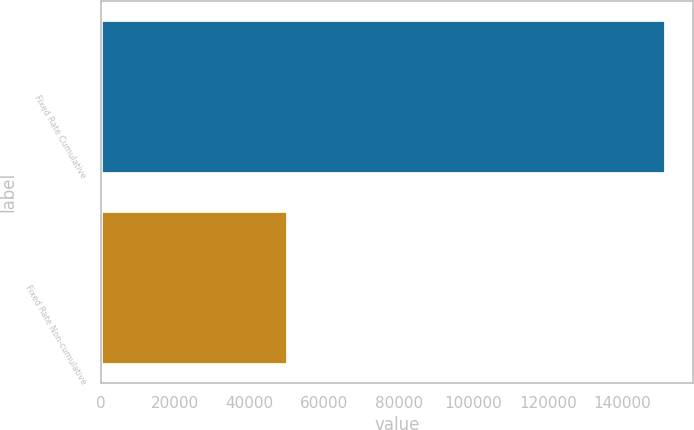Convert chart to OTSL. <chart><loc_0><loc_0><loc_500><loc_500><bar_chart><fcel>Fixed Rate Cumulative<fcel>Fixed Rate Non-cumulative<nl><fcel>151500<fcel>50000<nl></chart> 